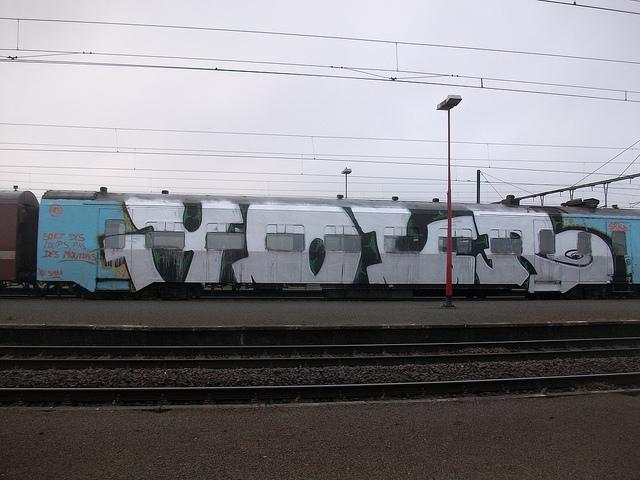What graffiti is on the train?
Concise answer only. White. What is graffiti on the train?
Give a very brief answer. White. Is this a real train?
Give a very brief answer. Yes. How many sections of the tram car is there?
Keep it brief. 1. Is the light on?
Be succinct. No. What is written in blue letters?
Give a very brief answer. Nothing. Is the blue object positioned at the beginning or at the end of the word in blue and red?
Be succinct. Beginning. What color is the train?
Answer briefly. Black. How many train tracks are visible?
Answer briefly. 2. Are there trees in this picture?
Answer briefly. No. How many cars are on the road?
Keep it brief. 0. What numbers are on the side of the train?
Quick response, please. 43. Has snow fallen?
Short answer required. No. Is this a left turn lane?
Give a very brief answer. No. What color train is this?
Concise answer only. White. Is the sky gray?
Answer briefly. Yes. 